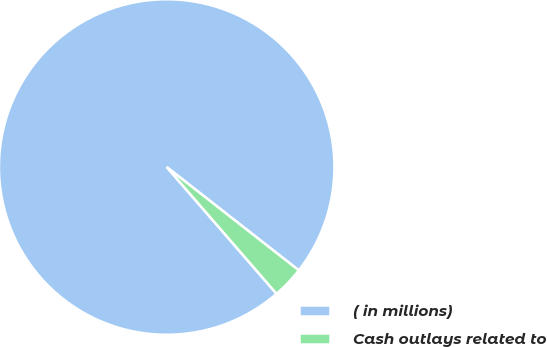Convert chart to OTSL. <chart><loc_0><loc_0><loc_500><loc_500><pie_chart><fcel>( in millions)<fcel>Cash outlays related to<nl><fcel>96.93%<fcel>3.07%<nl></chart> 